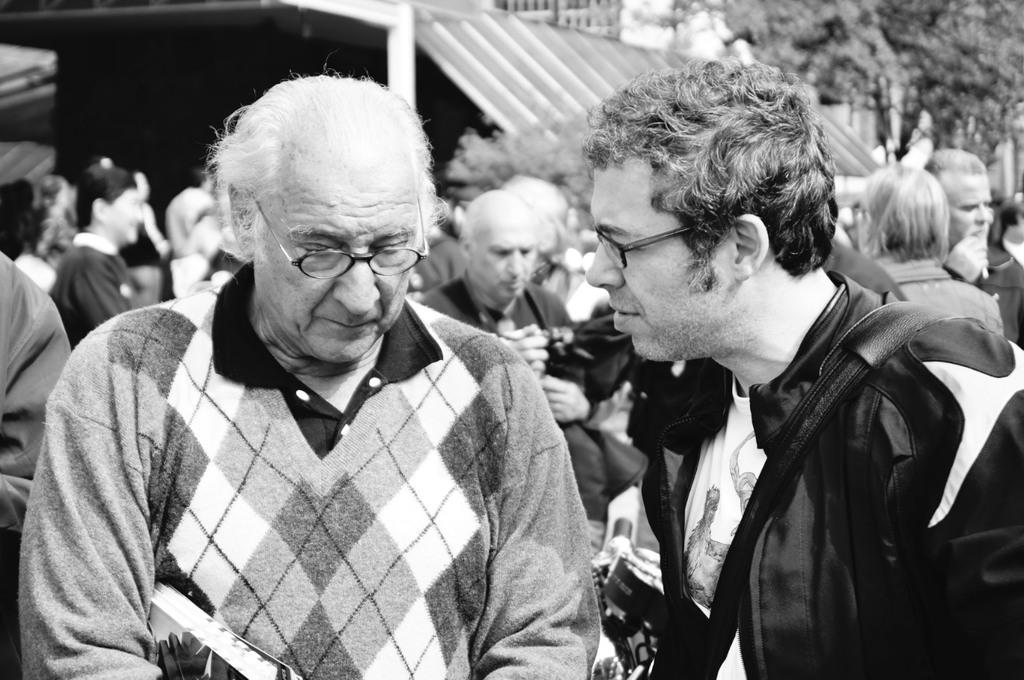What is the color scheme of the image? The image is black and white. Who or what can be seen in the image? There are people in the image. What structure is visible in the image? There is a roof in the image. What type of natural elements are present in the image? There are trees in the image. How many apples are hanging from the trees in the image? There are no apples visible in the image; only trees are present. What does the son of the person in the image look like? There is no information about a son or any other family members in the image. 